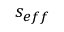<formula> <loc_0><loc_0><loc_500><loc_500>s _ { e f f }</formula> 